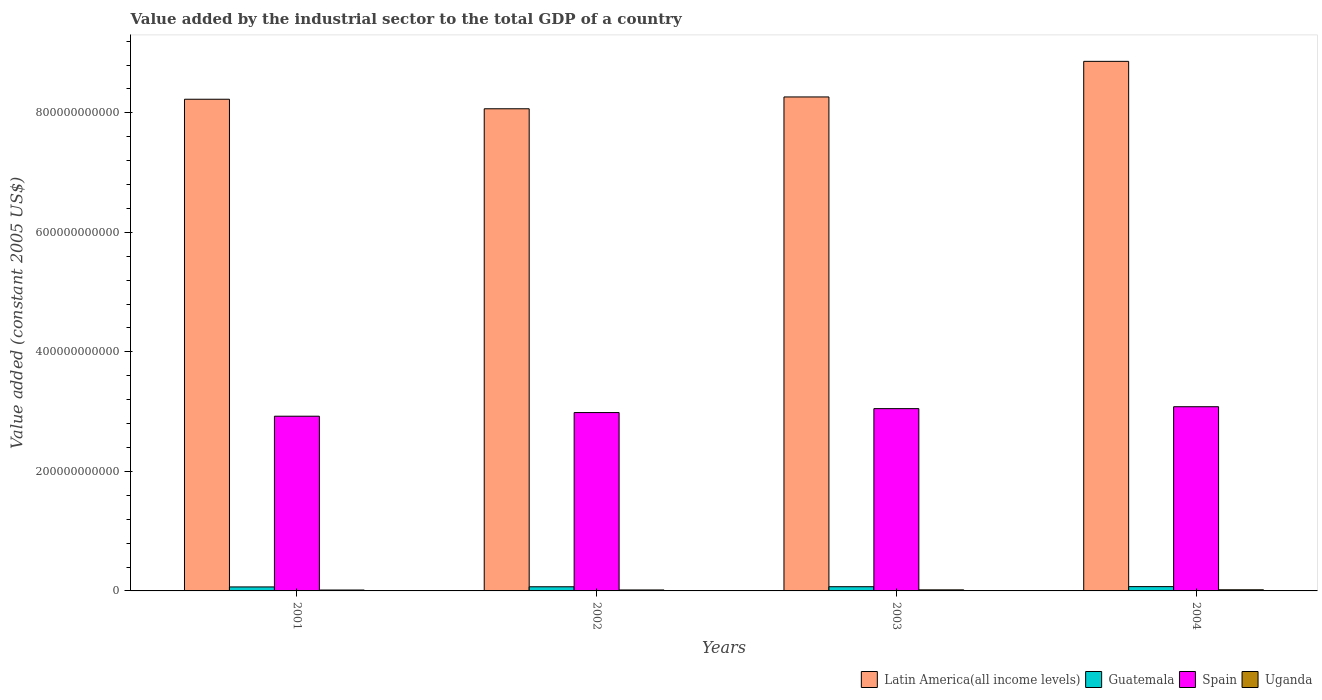Are the number of bars on each tick of the X-axis equal?
Provide a short and direct response. Yes. What is the value added by the industrial sector in Latin America(all income levels) in 2004?
Keep it short and to the point. 8.86e+11. Across all years, what is the maximum value added by the industrial sector in Latin America(all income levels)?
Your answer should be very brief. 8.86e+11. Across all years, what is the minimum value added by the industrial sector in Guatemala?
Offer a terse response. 6.67e+09. What is the total value added by the industrial sector in Spain in the graph?
Your answer should be compact. 1.20e+12. What is the difference between the value added by the industrial sector in Uganda in 2001 and that in 2004?
Offer a terse response. -4.04e+08. What is the difference between the value added by the industrial sector in Uganda in 2003 and the value added by the industrial sector in Spain in 2002?
Provide a short and direct response. -2.97e+11. What is the average value added by the industrial sector in Guatemala per year?
Keep it short and to the point. 6.96e+09. In the year 2003, what is the difference between the value added by the industrial sector in Guatemala and value added by the industrial sector in Uganda?
Make the answer very short. 5.28e+09. What is the ratio of the value added by the industrial sector in Guatemala in 2001 to that in 2003?
Your answer should be very brief. 0.95. Is the value added by the industrial sector in Latin America(all income levels) in 2001 less than that in 2002?
Keep it short and to the point. No. Is the difference between the value added by the industrial sector in Guatemala in 2001 and 2003 greater than the difference between the value added by the industrial sector in Uganda in 2001 and 2003?
Keep it short and to the point. No. What is the difference between the highest and the second highest value added by the industrial sector in Spain?
Make the answer very short. 3.20e+09. What is the difference between the highest and the lowest value added by the industrial sector in Uganda?
Offer a terse response. 4.04e+08. In how many years, is the value added by the industrial sector in Spain greater than the average value added by the industrial sector in Spain taken over all years?
Your answer should be very brief. 2. Is the sum of the value added by the industrial sector in Spain in 2002 and 2004 greater than the maximum value added by the industrial sector in Guatemala across all years?
Offer a very short reply. Yes. What does the 4th bar from the left in 2003 represents?
Offer a very short reply. Uganda. What does the 2nd bar from the right in 2002 represents?
Offer a terse response. Spain. Are all the bars in the graph horizontal?
Your answer should be compact. No. How many years are there in the graph?
Keep it short and to the point. 4. What is the difference between two consecutive major ticks on the Y-axis?
Your answer should be compact. 2.00e+11. How many legend labels are there?
Your response must be concise. 4. What is the title of the graph?
Offer a terse response. Value added by the industrial sector to the total GDP of a country. What is the label or title of the Y-axis?
Ensure brevity in your answer.  Value added (constant 2005 US$). What is the Value added (constant 2005 US$) in Latin America(all income levels) in 2001?
Keep it short and to the point. 8.23e+11. What is the Value added (constant 2005 US$) in Guatemala in 2001?
Ensure brevity in your answer.  6.67e+09. What is the Value added (constant 2005 US$) in Spain in 2001?
Your response must be concise. 2.92e+11. What is the Value added (constant 2005 US$) of Uganda in 2001?
Your answer should be compact. 1.50e+09. What is the Value added (constant 2005 US$) of Latin America(all income levels) in 2002?
Give a very brief answer. 8.07e+11. What is the Value added (constant 2005 US$) of Guatemala in 2002?
Give a very brief answer. 6.93e+09. What is the Value added (constant 2005 US$) of Spain in 2002?
Offer a terse response. 2.98e+11. What is the Value added (constant 2005 US$) in Uganda in 2002?
Your response must be concise. 1.61e+09. What is the Value added (constant 2005 US$) of Latin America(all income levels) in 2003?
Offer a very short reply. 8.27e+11. What is the Value added (constant 2005 US$) of Guatemala in 2003?
Your response must be concise. 7.04e+09. What is the Value added (constant 2005 US$) of Spain in 2003?
Offer a very short reply. 3.05e+11. What is the Value added (constant 2005 US$) of Uganda in 2003?
Offer a terse response. 1.76e+09. What is the Value added (constant 2005 US$) of Latin America(all income levels) in 2004?
Offer a very short reply. 8.86e+11. What is the Value added (constant 2005 US$) of Guatemala in 2004?
Make the answer very short. 7.19e+09. What is the Value added (constant 2005 US$) of Spain in 2004?
Provide a succinct answer. 3.08e+11. What is the Value added (constant 2005 US$) in Uganda in 2004?
Give a very brief answer. 1.90e+09. Across all years, what is the maximum Value added (constant 2005 US$) in Latin America(all income levels)?
Provide a short and direct response. 8.86e+11. Across all years, what is the maximum Value added (constant 2005 US$) in Guatemala?
Provide a short and direct response. 7.19e+09. Across all years, what is the maximum Value added (constant 2005 US$) of Spain?
Provide a short and direct response. 3.08e+11. Across all years, what is the maximum Value added (constant 2005 US$) of Uganda?
Your answer should be very brief. 1.90e+09. Across all years, what is the minimum Value added (constant 2005 US$) in Latin America(all income levels)?
Give a very brief answer. 8.07e+11. Across all years, what is the minimum Value added (constant 2005 US$) of Guatemala?
Offer a terse response. 6.67e+09. Across all years, what is the minimum Value added (constant 2005 US$) in Spain?
Give a very brief answer. 2.92e+11. Across all years, what is the minimum Value added (constant 2005 US$) of Uganda?
Provide a succinct answer. 1.50e+09. What is the total Value added (constant 2005 US$) in Latin America(all income levels) in the graph?
Provide a succinct answer. 3.34e+12. What is the total Value added (constant 2005 US$) of Guatemala in the graph?
Offer a very short reply. 2.78e+1. What is the total Value added (constant 2005 US$) in Spain in the graph?
Give a very brief answer. 1.20e+12. What is the total Value added (constant 2005 US$) in Uganda in the graph?
Provide a succinct answer. 6.76e+09. What is the difference between the Value added (constant 2005 US$) of Latin America(all income levels) in 2001 and that in 2002?
Keep it short and to the point. 1.59e+1. What is the difference between the Value added (constant 2005 US$) of Guatemala in 2001 and that in 2002?
Keep it short and to the point. -2.67e+08. What is the difference between the Value added (constant 2005 US$) of Spain in 2001 and that in 2002?
Provide a succinct answer. -6.08e+09. What is the difference between the Value added (constant 2005 US$) in Uganda in 2001 and that in 2002?
Offer a terse response. -1.11e+08. What is the difference between the Value added (constant 2005 US$) of Latin America(all income levels) in 2001 and that in 2003?
Ensure brevity in your answer.  -3.86e+09. What is the difference between the Value added (constant 2005 US$) of Guatemala in 2001 and that in 2003?
Offer a terse response. -3.70e+08. What is the difference between the Value added (constant 2005 US$) of Spain in 2001 and that in 2003?
Offer a very short reply. -1.27e+1. What is the difference between the Value added (constant 2005 US$) in Uganda in 2001 and that in 2003?
Ensure brevity in your answer.  -2.63e+08. What is the difference between the Value added (constant 2005 US$) in Latin America(all income levels) in 2001 and that in 2004?
Your answer should be compact. -6.34e+1. What is the difference between the Value added (constant 2005 US$) in Guatemala in 2001 and that in 2004?
Provide a short and direct response. -5.23e+08. What is the difference between the Value added (constant 2005 US$) in Spain in 2001 and that in 2004?
Your response must be concise. -1.59e+1. What is the difference between the Value added (constant 2005 US$) of Uganda in 2001 and that in 2004?
Keep it short and to the point. -4.04e+08. What is the difference between the Value added (constant 2005 US$) of Latin America(all income levels) in 2002 and that in 2003?
Your response must be concise. -1.98e+1. What is the difference between the Value added (constant 2005 US$) in Guatemala in 2002 and that in 2003?
Offer a very short reply. -1.03e+08. What is the difference between the Value added (constant 2005 US$) of Spain in 2002 and that in 2003?
Offer a very short reply. -6.59e+09. What is the difference between the Value added (constant 2005 US$) of Uganda in 2002 and that in 2003?
Your response must be concise. -1.52e+08. What is the difference between the Value added (constant 2005 US$) of Latin America(all income levels) in 2002 and that in 2004?
Give a very brief answer. -7.94e+1. What is the difference between the Value added (constant 2005 US$) in Guatemala in 2002 and that in 2004?
Provide a short and direct response. -2.56e+08. What is the difference between the Value added (constant 2005 US$) in Spain in 2002 and that in 2004?
Give a very brief answer. -9.79e+09. What is the difference between the Value added (constant 2005 US$) of Uganda in 2002 and that in 2004?
Your answer should be very brief. -2.93e+08. What is the difference between the Value added (constant 2005 US$) in Latin America(all income levels) in 2003 and that in 2004?
Keep it short and to the point. -5.95e+1. What is the difference between the Value added (constant 2005 US$) of Guatemala in 2003 and that in 2004?
Offer a terse response. -1.53e+08. What is the difference between the Value added (constant 2005 US$) in Spain in 2003 and that in 2004?
Your answer should be very brief. -3.20e+09. What is the difference between the Value added (constant 2005 US$) in Uganda in 2003 and that in 2004?
Offer a terse response. -1.41e+08. What is the difference between the Value added (constant 2005 US$) in Latin America(all income levels) in 2001 and the Value added (constant 2005 US$) in Guatemala in 2002?
Provide a short and direct response. 8.16e+11. What is the difference between the Value added (constant 2005 US$) in Latin America(all income levels) in 2001 and the Value added (constant 2005 US$) in Spain in 2002?
Your answer should be compact. 5.24e+11. What is the difference between the Value added (constant 2005 US$) in Latin America(all income levels) in 2001 and the Value added (constant 2005 US$) in Uganda in 2002?
Your response must be concise. 8.21e+11. What is the difference between the Value added (constant 2005 US$) in Guatemala in 2001 and the Value added (constant 2005 US$) in Spain in 2002?
Provide a short and direct response. -2.92e+11. What is the difference between the Value added (constant 2005 US$) in Guatemala in 2001 and the Value added (constant 2005 US$) in Uganda in 2002?
Your answer should be compact. 5.06e+09. What is the difference between the Value added (constant 2005 US$) in Spain in 2001 and the Value added (constant 2005 US$) in Uganda in 2002?
Keep it short and to the point. 2.91e+11. What is the difference between the Value added (constant 2005 US$) of Latin America(all income levels) in 2001 and the Value added (constant 2005 US$) of Guatemala in 2003?
Offer a very short reply. 8.16e+11. What is the difference between the Value added (constant 2005 US$) in Latin America(all income levels) in 2001 and the Value added (constant 2005 US$) in Spain in 2003?
Your response must be concise. 5.18e+11. What is the difference between the Value added (constant 2005 US$) in Latin America(all income levels) in 2001 and the Value added (constant 2005 US$) in Uganda in 2003?
Give a very brief answer. 8.21e+11. What is the difference between the Value added (constant 2005 US$) of Guatemala in 2001 and the Value added (constant 2005 US$) of Spain in 2003?
Provide a short and direct response. -2.98e+11. What is the difference between the Value added (constant 2005 US$) in Guatemala in 2001 and the Value added (constant 2005 US$) in Uganda in 2003?
Your answer should be very brief. 4.91e+09. What is the difference between the Value added (constant 2005 US$) in Spain in 2001 and the Value added (constant 2005 US$) in Uganda in 2003?
Provide a succinct answer. 2.91e+11. What is the difference between the Value added (constant 2005 US$) of Latin America(all income levels) in 2001 and the Value added (constant 2005 US$) of Guatemala in 2004?
Provide a short and direct response. 8.16e+11. What is the difference between the Value added (constant 2005 US$) of Latin America(all income levels) in 2001 and the Value added (constant 2005 US$) of Spain in 2004?
Your response must be concise. 5.15e+11. What is the difference between the Value added (constant 2005 US$) of Latin America(all income levels) in 2001 and the Value added (constant 2005 US$) of Uganda in 2004?
Your answer should be compact. 8.21e+11. What is the difference between the Value added (constant 2005 US$) of Guatemala in 2001 and the Value added (constant 2005 US$) of Spain in 2004?
Give a very brief answer. -3.02e+11. What is the difference between the Value added (constant 2005 US$) of Guatemala in 2001 and the Value added (constant 2005 US$) of Uganda in 2004?
Give a very brief answer. 4.77e+09. What is the difference between the Value added (constant 2005 US$) in Spain in 2001 and the Value added (constant 2005 US$) in Uganda in 2004?
Your response must be concise. 2.90e+11. What is the difference between the Value added (constant 2005 US$) in Latin America(all income levels) in 2002 and the Value added (constant 2005 US$) in Guatemala in 2003?
Your response must be concise. 8.00e+11. What is the difference between the Value added (constant 2005 US$) of Latin America(all income levels) in 2002 and the Value added (constant 2005 US$) of Spain in 2003?
Provide a succinct answer. 5.02e+11. What is the difference between the Value added (constant 2005 US$) of Latin America(all income levels) in 2002 and the Value added (constant 2005 US$) of Uganda in 2003?
Offer a terse response. 8.05e+11. What is the difference between the Value added (constant 2005 US$) in Guatemala in 2002 and the Value added (constant 2005 US$) in Spain in 2003?
Your answer should be very brief. -2.98e+11. What is the difference between the Value added (constant 2005 US$) in Guatemala in 2002 and the Value added (constant 2005 US$) in Uganda in 2003?
Ensure brevity in your answer.  5.18e+09. What is the difference between the Value added (constant 2005 US$) of Spain in 2002 and the Value added (constant 2005 US$) of Uganda in 2003?
Your answer should be compact. 2.97e+11. What is the difference between the Value added (constant 2005 US$) in Latin America(all income levels) in 2002 and the Value added (constant 2005 US$) in Guatemala in 2004?
Provide a short and direct response. 8.00e+11. What is the difference between the Value added (constant 2005 US$) in Latin America(all income levels) in 2002 and the Value added (constant 2005 US$) in Spain in 2004?
Provide a succinct answer. 4.99e+11. What is the difference between the Value added (constant 2005 US$) of Latin America(all income levels) in 2002 and the Value added (constant 2005 US$) of Uganda in 2004?
Ensure brevity in your answer.  8.05e+11. What is the difference between the Value added (constant 2005 US$) in Guatemala in 2002 and the Value added (constant 2005 US$) in Spain in 2004?
Keep it short and to the point. -3.01e+11. What is the difference between the Value added (constant 2005 US$) of Guatemala in 2002 and the Value added (constant 2005 US$) of Uganda in 2004?
Your answer should be very brief. 5.04e+09. What is the difference between the Value added (constant 2005 US$) in Spain in 2002 and the Value added (constant 2005 US$) in Uganda in 2004?
Your response must be concise. 2.97e+11. What is the difference between the Value added (constant 2005 US$) in Latin America(all income levels) in 2003 and the Value added (constant 2005 US$) in Guatemala in 2004?
Provide a short and direct response. 8.19e+11. What is the difference between the Value added (constant 2005 US$) in Latin America(all income levels) in 2003 and the Value added (constant 2005 US$) in Spain in 2004?
Keep it short and to the point. 5.18e+11. What is the difference between the Value added (constant 2005 US$) in Latin America(all income levels) in 2003 and the Value added (constant 2005 US$) in Uganda in 2004?
Your answer should be very brief. 8.25e+11. What is the difference between the Value added (constant 2005 US$) of Guatemala in 2003 and the Value added (constant 2005 US$) of Spain in 2004?
Your response must be concise. -3.01e+11. What is the difference between the Value added (constant 2005 US$) of Guatemala in 2003 and the Value added (constant 2005 US$) of Uganda in 2004?
Your answer should be compact. 5.14e+09. What is the difference between the Value added (constant 2005 US$) in Spain in 2003 and the Value added (constant 2005 US$) in Uganda in 2004?
Offer a very short reply. 3.03e+11. What is the average Value added (constant 2005 US$) in Latin America(all income levels) per year?
Provide a short and direct response. 8.36e+11. What is the average Value added (constant 2005 US$) of Guatemala per year?
Make the answer very short. 6.96e+09. What is the average Value added (constant 2005 US$) in Spain per year?
Keep it short and to the point. 3.01e+11. What is the average Value added (constant 2005 US$) in Uganda per year?
Your response must be concise. 1.69e+09. In the year 2001, what is the difference between the Value added (constant 2005 US$) in Latin America(all income levels) and Value added (constant 2005 US$) in Guatemala?
Offer a terse response. 8.16e+11. In the year 2001, what is the difference between the Value added (constant 2005 US$) of Latin America(all income levels) and Value added (constant 2005 US$) of Spain?
Keep it short and to the point. 5.30e+11. In the year 2001, what is the difference between the Value added (constant 2005 US$) in Latin America(all income levels) and Value added (constant 2005 US$) in Uganda?
Offer a very short reply. 8.21e+11. In the year 2001, what is the difference between the Value added (constant 2005 US$) of Guatemala and Value added (constant 2005 US$) of Spain?
Offer a very short reply. -2.86e+11. In the year 2001, what is the difference between the Value added (constant 2005 US$) of Guatemala and Value added (constant 2005 US$) of Uganda?
Offer a very short reply. 5.17e+09. In the year 2001, what is the difference between the Value added (constant 2005 US$) of Spain and Value added (constant 2005 US$) of Uganda?
Your answer should be very brief. 2.91e+11. In the year 2002, what is the difference between the Value added (constant 2005 US$) in Latin America(all income levels) and Value added (constant 2005 US$) in Guatemala?
Ensure brevity in your answer.  8.00e+11. In the year 2002, what is the difference between the Value added (constant 2005 US$) in Latin America(all income levels) and Value added (constant 2005 US$) in Spain?
Your response must be concise. 5.08e+11. In the year 2002, what is the difference between the Value added (constant 2005 US$) in Latin America(all income levels) and Value added (constant 2005 US$) in Uganda?
Your response must be concise. 8.05e+11. In the year 2002, what is the difference between the Value added (constant 2005 US$) of Guatemala and Value added (constant 2005 US$) of Spain?
Give a very brief answer. -2.92e+11. In the year 2002, what is the difference between the Value added (constant 2005 US$) in Guatemala and Value added (constant 2005 US$) in Uganda?
Provide a succinct answer. 5.33e+09. In the year 2002, what is the difference between the Value added (constant 2005 US$) in Spain and Value added (constant 2005 US$) in Uganda?
Your response must be concise. 2.97e+11. In the year 2003, what is the difference between the Value added (constant 2005 US$) in Latin America(all income levels) and Value added (constant 2005 US$) in Guatemala?
Your answer should be very brief. 8.20e+11. In the year 2003, what is the difference between the Value added (constant 2005 US$) in Latin America(all income levels) and Value added (constant 2005 US$) in Spain?
Your response must be concise. 5.22e+11. In the year 2003, what is the difference between the Value added (constant 2005 US$) of Latin America(all income levels) and Value added (constant 2005 US$) of Uganda?
Offer a terse response. 8.25e+11. In the year 2003, what is the difference between the Value added (constant 2005 US$) of Guatemala and Value added (constant 2005 US$) of Spain?
Offer a terse response. -2.98e+11. In the year 2003, what is the difference between the Value added (constant 2005 US$) in Guatemala and Value added (constant 2005 US$) in Uganda?
Your answer should be very brief. 5.28e+09. In the year 2003, what is the difference between the Value added (constant 2005 US$) of Spain and Value added (constant 2005 US$) of Uganda?
Provide a short and direct response. 3.03e+11. In the year 2004, what is the difference between the Value added (constant 2005 US$) of Latin America(all income levels) and Value added (constant 2005 US$) of Guatemala?
Provide a succinct answer. 8.79e+11. In the year 2004, what is the difference between the Value added (constant 2005 US$) of Latin America(all income levels) and Value added (constant 2005 US$) of Spain?
Your answer should be compact. 5.78e+11. In the year 2004, what is the difference between the Value added (constant 2005 US$) in Latin America(all income levels) and Value added (constant 2005 US$) in Uganda?
Offer a terse response. 8.84e+11. In the year 2004, what is the difference between the Value added (constant 2005 US$) in Guatemala and Value added (constant 2005 US$) in Spain?
Your response must be concise. -3.01e+11. In the year 2004, what is the difference between the Value added (constant 2005 US$) of Guatemala and Value added (constant 2005 US$) of Uganda?
Your answer should be very brief. 5.29e+09. In the year 2004, what is the difference between the Value added (constant 2005 US$) of Spain and Value added (constant 2005 US$) of Uganda?
Make the answer very short. 3.06e+11. What is the ratio of the Value added (constant 2005 US$) in Latin America(all income levels) in 2001 to that in 2002?
Provide a succinct answer. 1.02. What is the ratio of the Value added (constant 2005 US$) in Guatemala in 2001 to that in 2002?
Provide a short and direct response. 0.96. What is the ratio of the Value added (constant 2005 US$) in Spain in 2001 to that in 2002?
Your response must be concise. 0.98. What is the ratio of the Value added (constant 2005 US$) of Uganda in 2001 to that in 2002?
Your response must be concise. 0.93. What is the ratio of the Value added (constant 2005 US$) in Latin America(all income levels) in 2001 to that in 2003?
Offer a terse response. 1. What is the ratio of the Value added (constant 2005 US$) of Guatemala in 2001 to that in 2003?
Provide a succinct answer. 0.95. What is the ratio of the Value added (constant 2005 US$) of Spain in 2001 to that in 2003?
Give a very brief answer. 0.96. What is the ratio of the Value added (constant 2005 US$) in Uganda in 2001 to that in 2003?
Give a very brief answer. 0.85. What is the ratio of the Value added (constant 2005 US$) in Latin America(all income levels) in 2001 to that in 2004?
Make the answer very short. 0.93. What is the ratio of the Value added (constant 2005 US$) in Guatemala in 2001 to that in 2004?
Your response must be concise. 0.93. What is the ratio of the Value added (constant 2005 US$) of Spain in 2001 to that in 2004?
Keep it short and to the point. 0.95. What is the ratio of the Value added (constant 2005 US$) of Uganda in 2001 to that in 2004?
Your answer should be compact. 0.79. What is the ratio of the Value added (constant 2005 US$) in Guatemala in 2002 to that in 2003?
Ensure brevity in your answer.  0.99. What is the ratio of the Value added (constant 2005 US$) in Spain in 2002 to that in 2003?
Your answer should be very brief. 0.98. What is the ratio of the Value added (constant 2005 US$) of Uganda in 2002 to that in 2003?
Offer a very short reply. 0.91. What is the ratio of the Value added (constant 2005 US$) of Latin America(all income levels) in 2002 to that in 2004?
Your answer should be very brief. 0.91. What is the ratio of the Value added (constant 2005 US$) of Guatemala in 2002 to that in 2004?
Provide a succinct answer. 0.96. What is the ratio of the Value added (constant 2005 US$) of Spain in 2002 to that in 2004?
Your response must be concise. 0.97. What is the ratio of the Value added (constant 2005 US$) in Uganda in 2002 to that in 2004?
Provide a succinct answer. 0.85. What is the ratio of the Value added (constant 2005 US$) of Latin America(all income levels) in 2003 to that in 2004?
Give a very brief answer. 0.93. What is the ratio of the Value added (constant 2005 US$) of Guatemala in 2003 to that in 2004?
Provide a succinct answer. 0.98. What is the ratio of the Value added (constant 2005 US$) in Spain in 2003 to that in 2004?
Make the answer very short. 0.99. What is the ratio of the Value added (constant 2005 US$) in Uganda in 2003 to that in 2004?
Ensure brevity in your answer.  0.93. What is the difference between the highest and the second highest Value added (constant 2005 US$) in Latin America(all income levels)?
Your answer should be compact. 5.95e+1. What is the difference between the highest and the second highest Value added (constant 2005 US$) in Guatemala?
Offer a terse response. 1.53e+08. What is the difference between the highest and the second highest Value added (constant 2005 US$) in Spain?
Your answer should be compact. 3.20e+09. What is the difference between the highest and the second highest Value added (constant 2005 US$) in Uganda?
Your answer should be compact. 1.41e+08. What is the difference between the highest and the lowest Value added (constant 2005 US$) in Latin America(all income levels)?
Keep it short and to the point. 7.94e+1. What is the difference between the highest and the lowest Value added (constant 2005 US$) of Guatemala?
Offer a very short reply. 5.23e+08. What is the difference between the highest and the lowest Value added (constant 2005 US$) in Spain?
Give a very brief answer. 1.59e+1. What is the difference between the highest and the lowest Value added (constant 2005 US$) in Uganda?
Offer a very short reply. 4.04e+08. 